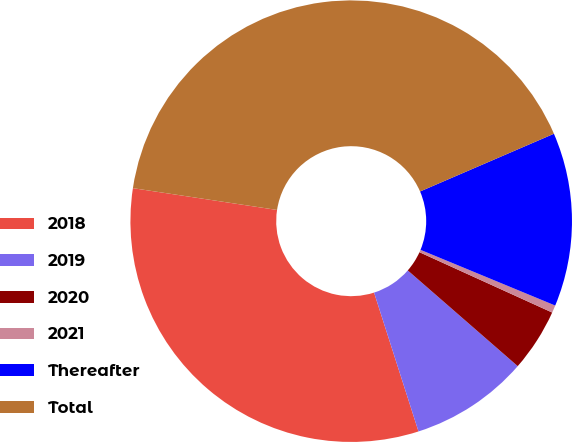Convert chart to OTSL. <chart><loc_0><loc_0><loc_500><loc_500><pie_chart><fcel>2018<fcel>2019<fcel>2020<fcel>2021<fcel>Thereafter<fcel>Total<nl><fcel>32.32%<fcel>8.67%<fcel>4.61%<fcel>0.55%<fcel>12.72%<fcel>41.13%<nl></chart> 